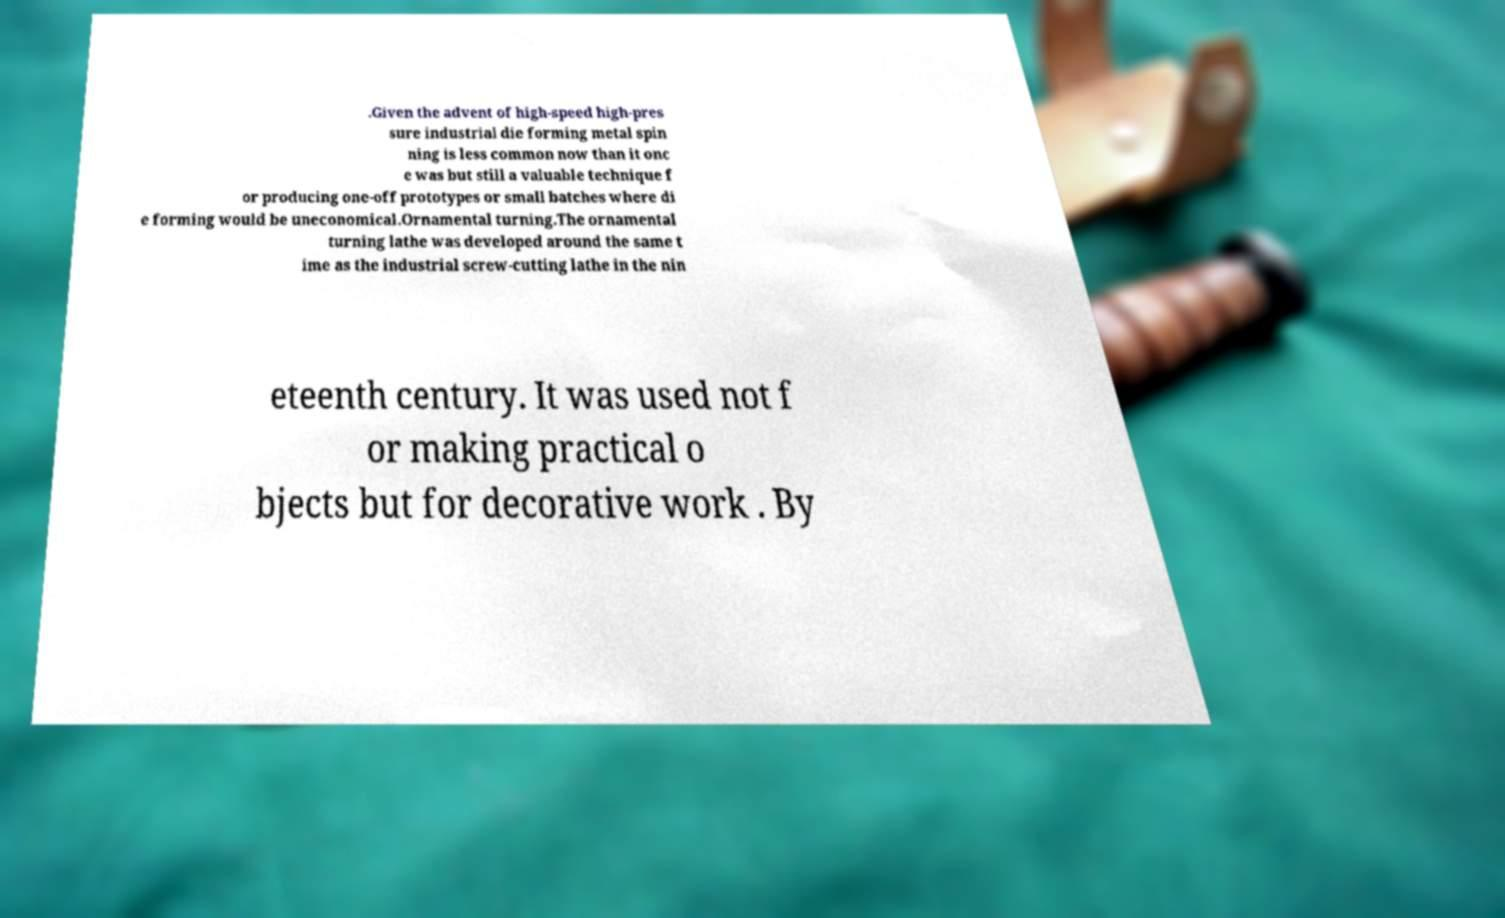For documentation purposes, I need the text within this image transcribed. Could you provide that? .Given the advent of high-speed high-pres sure industrial die forming metal spin ning is less common now than it onc e was but still a valuable technique f or producing one-off prototypes or small batches where di e forming would be uneconomical.Ornamental turning.The ornamental turning lathe was developed around the same t ime as the industrial screw-cutting lathe in the nin eteenth century. It was used not f or making practical o bjects but for decorative work . By 